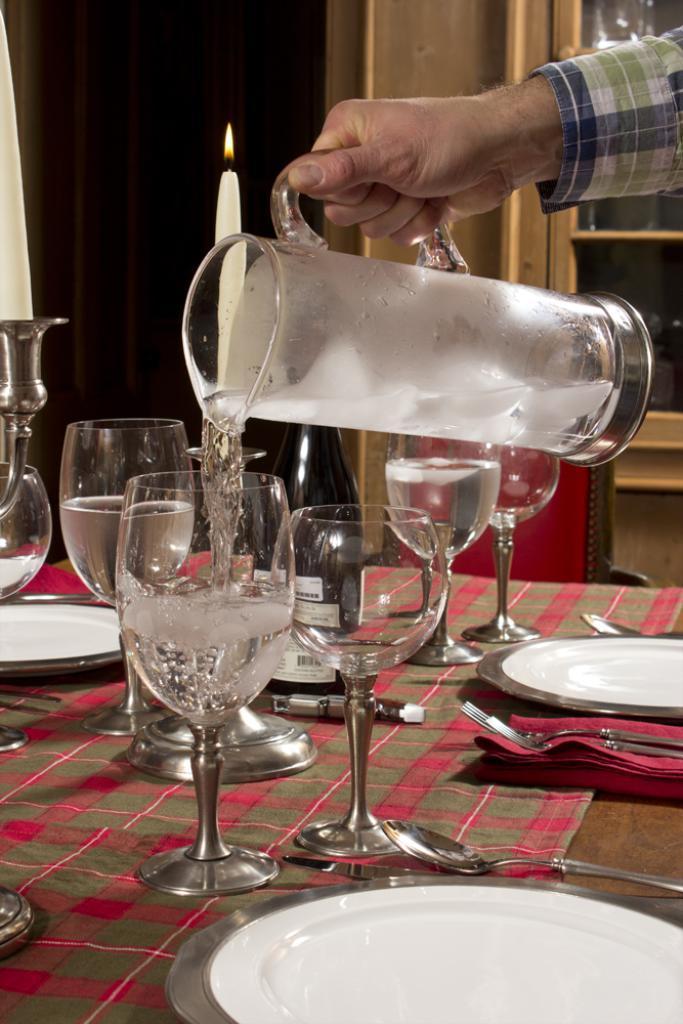Please provide a concise description of this image. Bottom of the image there is a table on the table there are some glasses and plates and spoons and forks. Top right side of the image a man is holding a jar. 